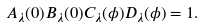Convert formula to latex. <formula><loc_0><loc_0><loc_500><loc_500>A _ { \lambda } ( 0 ) B _ { \lambda } ( 0 ) C _ { \lambda } ( \phi ) D _ { \lambda } ( \phi ) = 1 .</formula> 